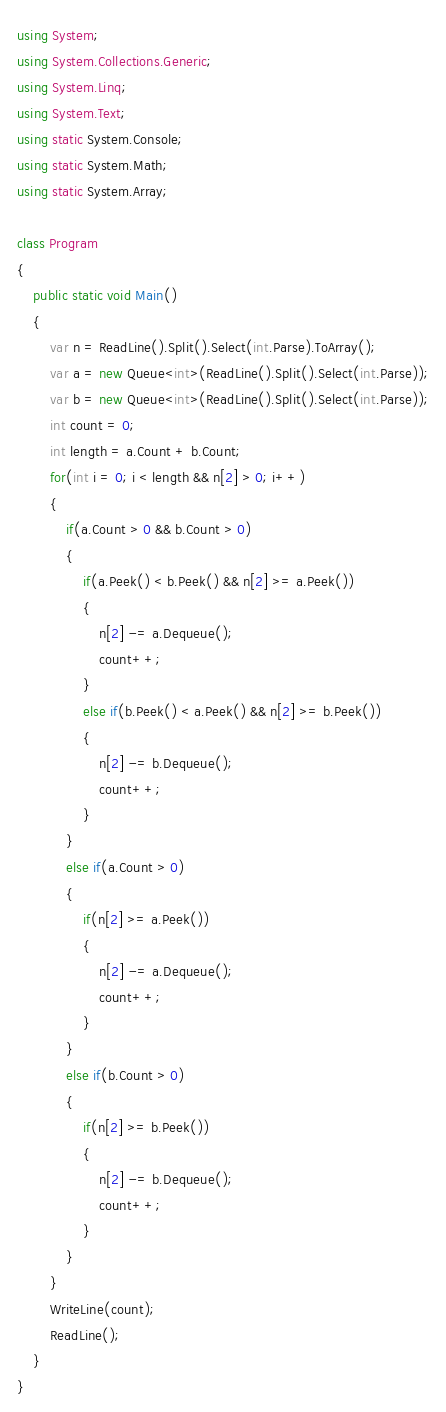Convert code to text. <code><loc_0><loc_0><loc_500><loc_500><_C#_>using System;
using System.Collections.Generic;
using System.Linq;
using System.Text;
using static System.Console;
using static System.Math;
using static System.Array;

class Program
{
    public static void Main()
    {
        var n = ReadLine().Split().Select(int.Parse).ToArray();
        var a = new Queue<int>(ReadLine().Split().Select(int.Parse));
        var b = new Queue<int>(ReadLine().Split().Select(int.Parse));
        int count = 0;
        int length = a.Count + b.Count;
        for(int i = 0; i < length && n[2] > 0; i++)
        {
            if(a.Count > 0 && b.Count > 0)
            {
                if(a.Peek() < b.Peek() && n[2] >= a.Peek())
                {
                    n[2] -= a.Dequeue();
                    count++;
                }
                else if(b.Peek() < a.Peek() && n[2] >= b.Peek())
                {
                    n[2] -= b.Dequeue();
                    count++;
                }
            }
            else if(a.Count > 0)
            {
                if(n[2] >= a.Peek())
                {
                    n[2] -= a.Dequeue();
                    count++;
                }
            }
            else if(b.Count > 0)
            {
                if(n[2] >= b.Peek())
                {
                    n[2] -= b.Dequeue();
                    count++;
                }
            }
        }
        WriteLine(count);
        ReadLine();
    }
}
</code> 